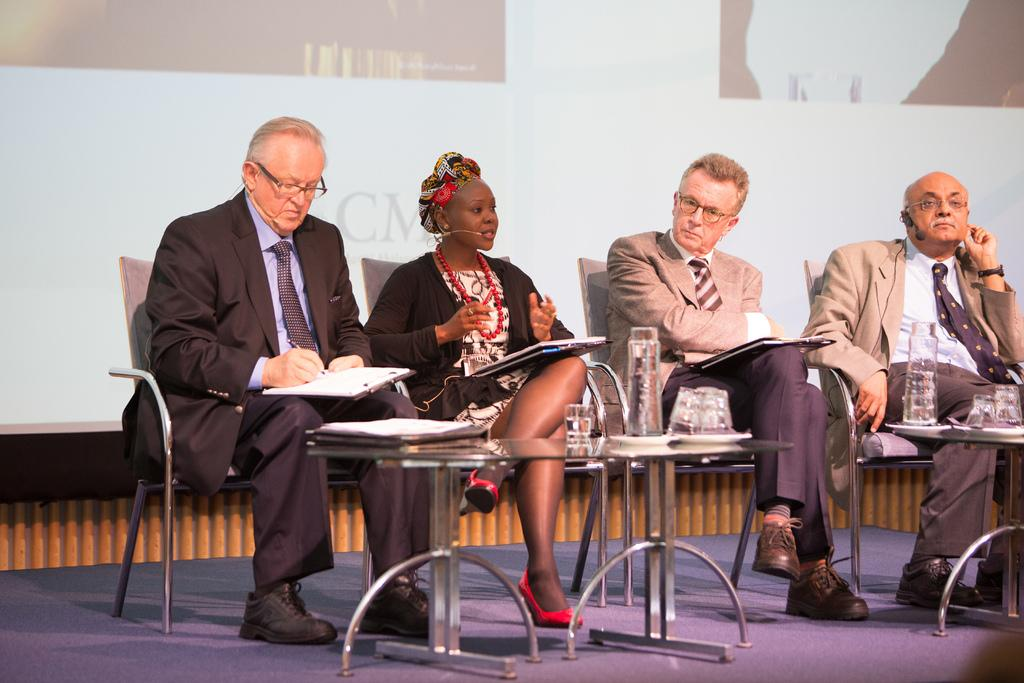How many people are in the image? There is a group of people in the image. What are the people doing in the image? The people are sitting in front of a teapoy. What else can be seen in the image besides the people? There is a screen visible in the image. What type of pollution is being discussed by the people in the image? There is no indication in the image that the people are discussing any type of pollution. 